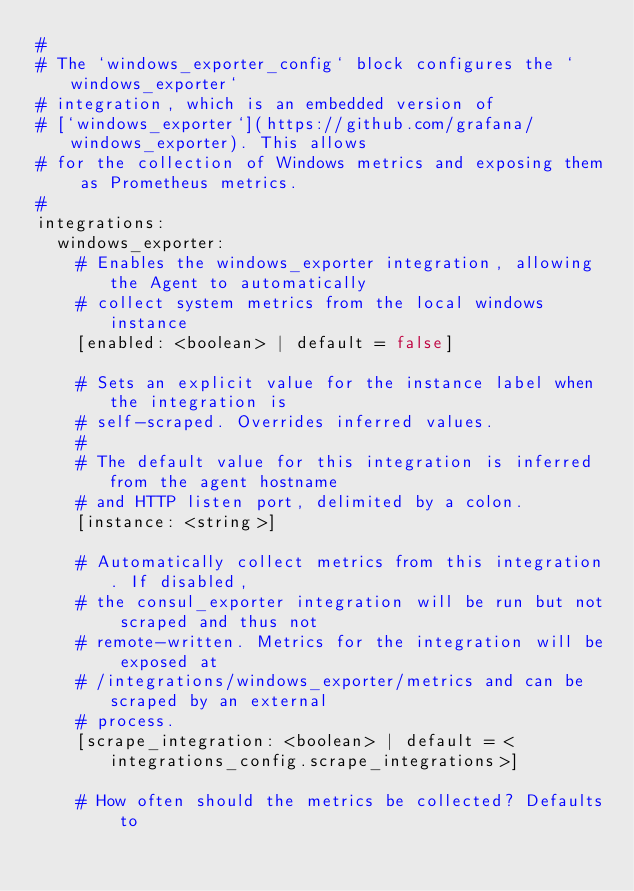Convert code to text. <code><loc_0><loc_0><loc_500><loc_500><_YAML_>#
# The `windows_exporter_config` block configures the `windows_exporter`
# integration, which is an embedded version of
# [`windows_exporter`](https://github.com/grafana/windows_exporter). This allows
# for the collection of Windows metrics and exposing them as Prometheus metrics.
#
integrations:
  windows_exporter:
    # Enables the windows_exporter integration, allowing the Agent to automatically
    # collect system metrics from the local windows instance
    [enabled: <boolean> | default = false]

    # Sets an explicit value for the instance label when the integration is
    # self-scraped. Overrides inferred values.
    #
    # The default value for this integration is inferred from the agent hostname
    # and HTTP listen port, delimited by a colon.
    [instance: <string>]

    # Automatically collect metrics from this integration. If disabled,
    # the consul_exporter integration will be run but not scraped and thus not
    # remote-written. Metrics for the integration will be exposed at
    # /integrations/windows_exporter/metrics and can be scraped by an external
    # process.
    [scrape_integration: <boolean> | default = <integrations_config.scrape_integrations>]

    # How often should the metrics be collected? Defaults to</code> 